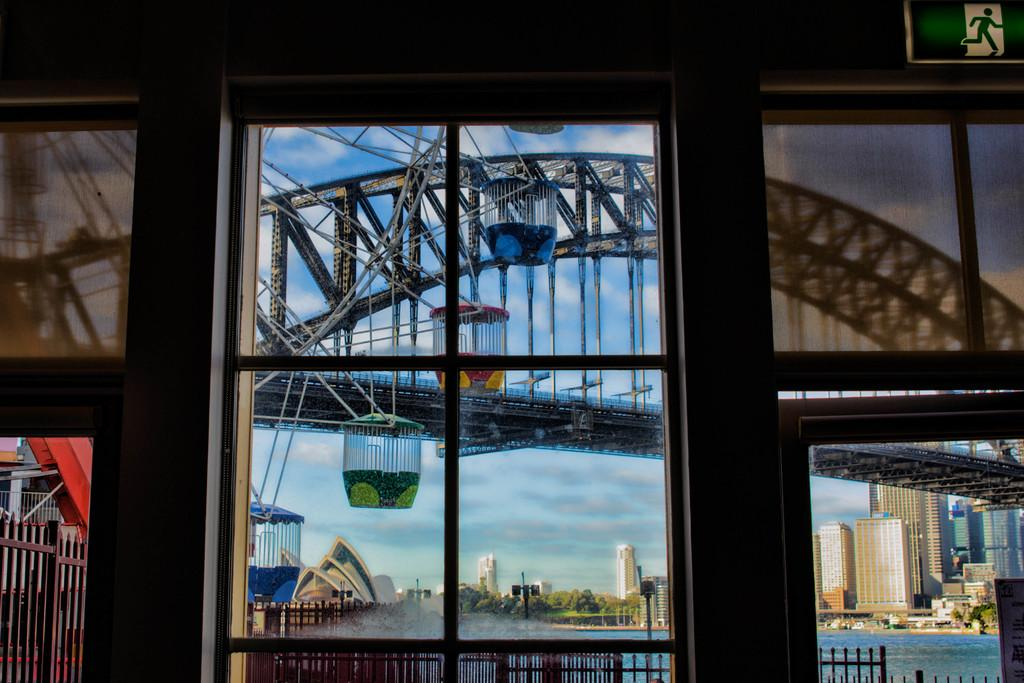What type of structures can be seen in the image? There are buildings in the image. What natural elements are present in the image? There are trees in the image. What type of lighting is present in the image? There are street lights in the image. What additional objects can be seen in the image? There are poles and a wheel in the center of the image. What type of man-made structure is present in the image? There is a bridge in the image. What part of the natural environment is visible in the background of the image? The sky is visible in the background of the image. Can you see a volcano erupting in the image? No, there is no volcano present in the image. Is the moon visible in the sky in the image? No, the moon is not visible in the sky in the image; only the sky is visible. 